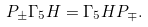Convert formula to latex. <formula><loc_0><loc_0><loc_500><loc_500>P _ { \pm } \Gamma _ { 5 } H = \Gamma _ { 5 } H P _ { \mp } .</formula> 